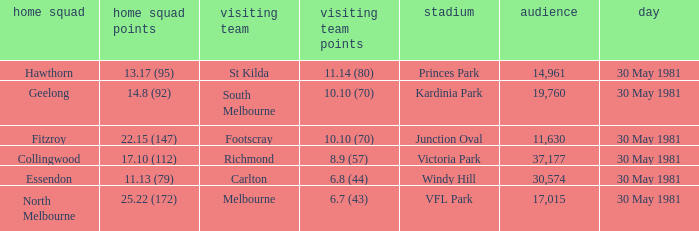What is the home venue of essendon with a crowd larger than 19,760? Windy Hill. 